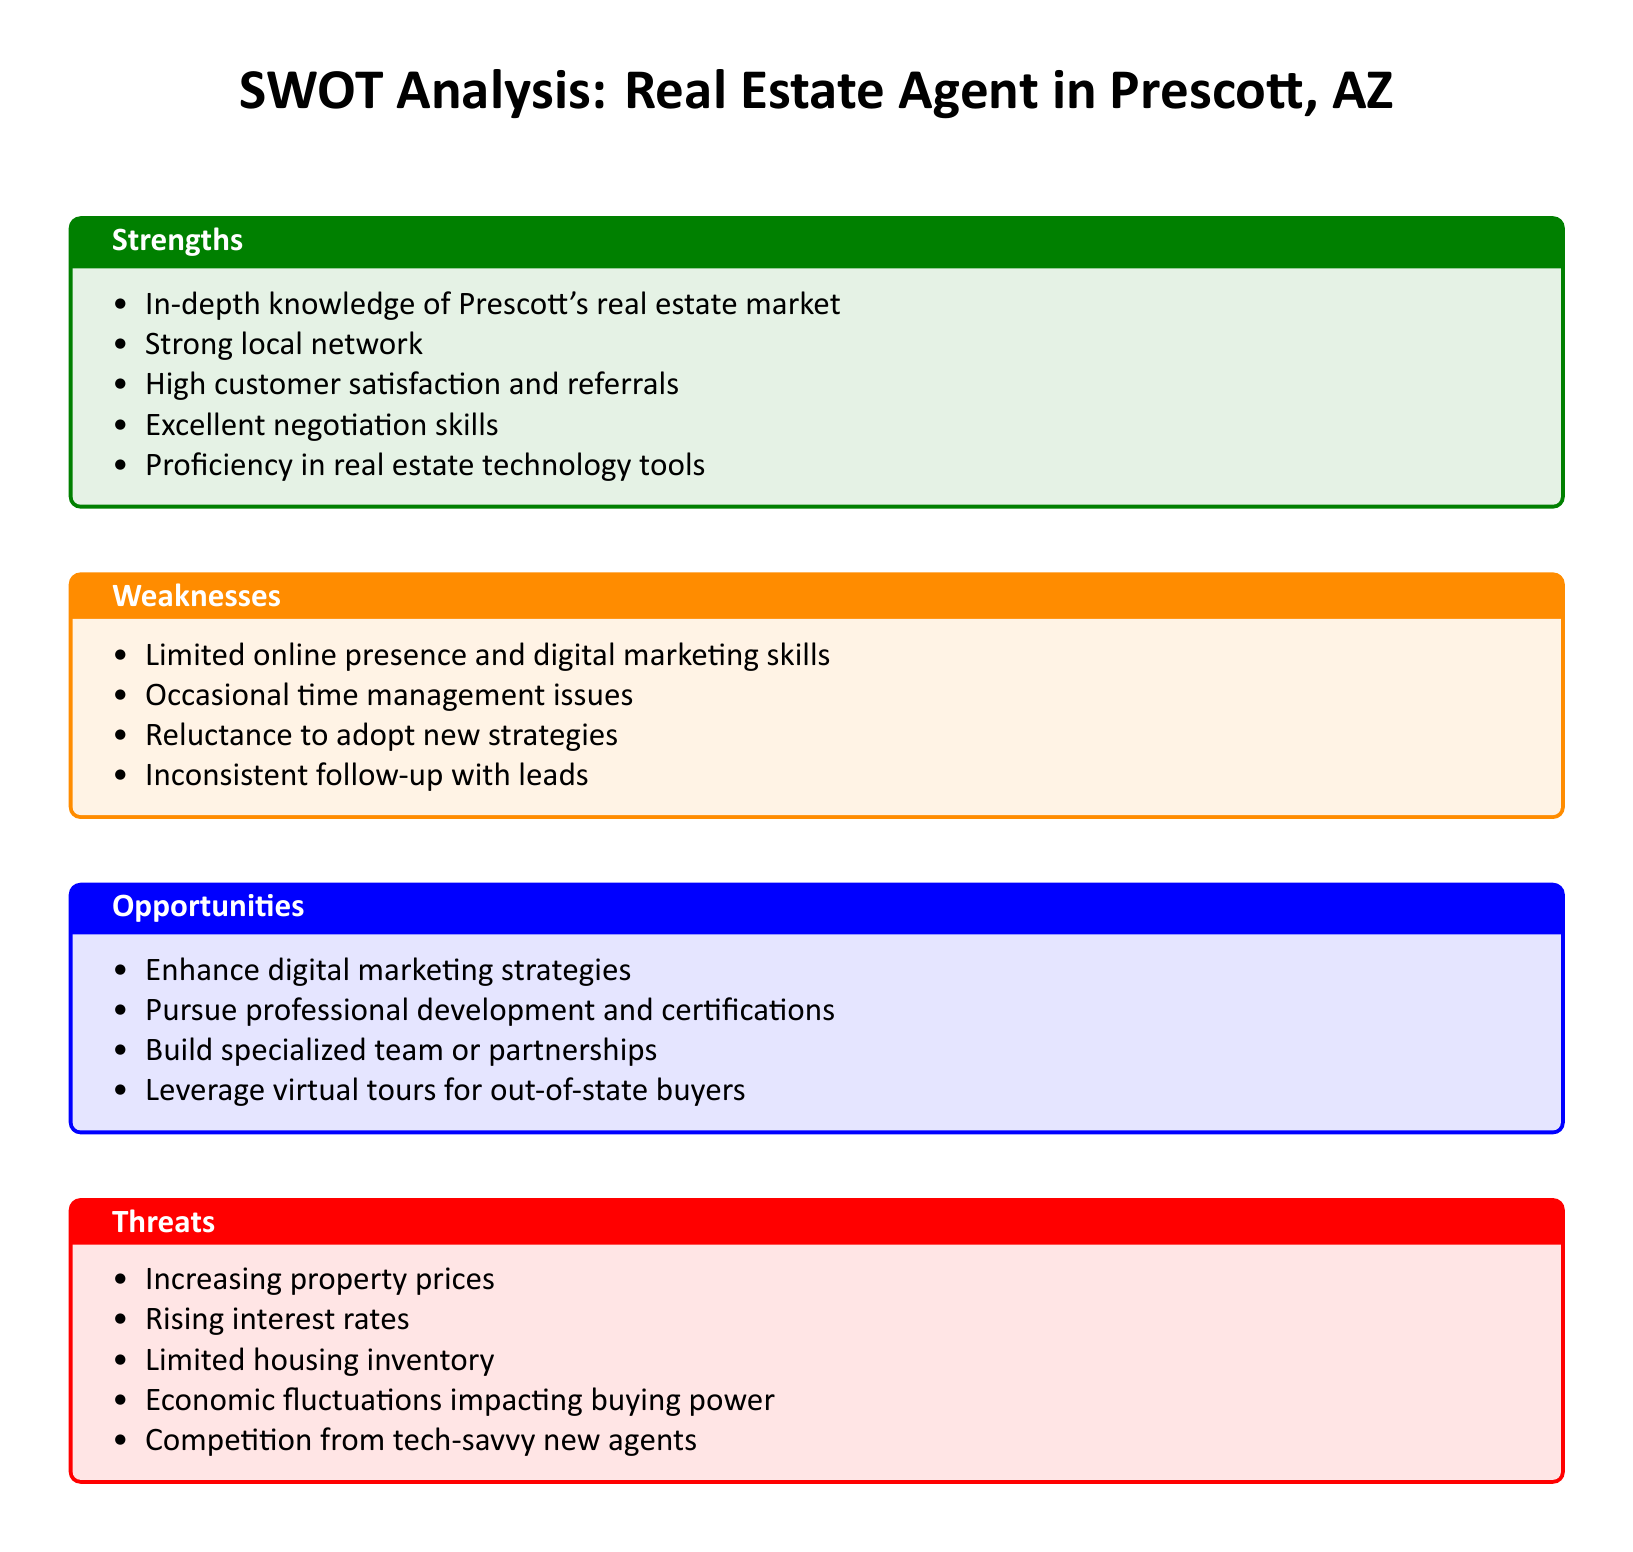What is one strength of the real estate agent? The strengths section lists various attributes of the agent, including in-depth knowledge of the Prescott's real estate market.
Answer: In-depth knowledge of Prescott's real estate market Which weakness relates to follow-up? The weaknesses section mentions an inconsistency in how the agent interacts with prospects, highlighting the issue of following up with leads.
Answer: Inconsistent follow-up with leads Name one opportunity for growth mentioned in the document. The opportunities section discusses potential paths for professional or business improvement, including the enhancement of digital marketing strategies.
Answer: Enhance digital marketing strategies What threat is caused by market conditions? The threats section covers external challenges, including rising interest rates, which affect market dynamics.
Answer: Rising interest rates Which skill is highlighted as a strength? Among the strengths listed, excellent negotiation skills are mentioned as a key asset of the agent.
Answer: Excellent negotiation skills What color is used for weaknesses? The document specifies color coding for each section, with weaknesses represented in orange.
Answer: Orange How many opportunities for growth are listed? The opportunities section contains four specific strategies for growth.
Answer: Four Which factor impacts buying power according to the threats? The document identifies economic fluctuations as a factor that can influence buyers' purchasing power in the market.
Answer: Economic fluctuations What is one local characteristic that benefits the agent? The strengths section indicates that a strong local network is an asset for the real estate agent in Prescott.
Answer: Strong local network 